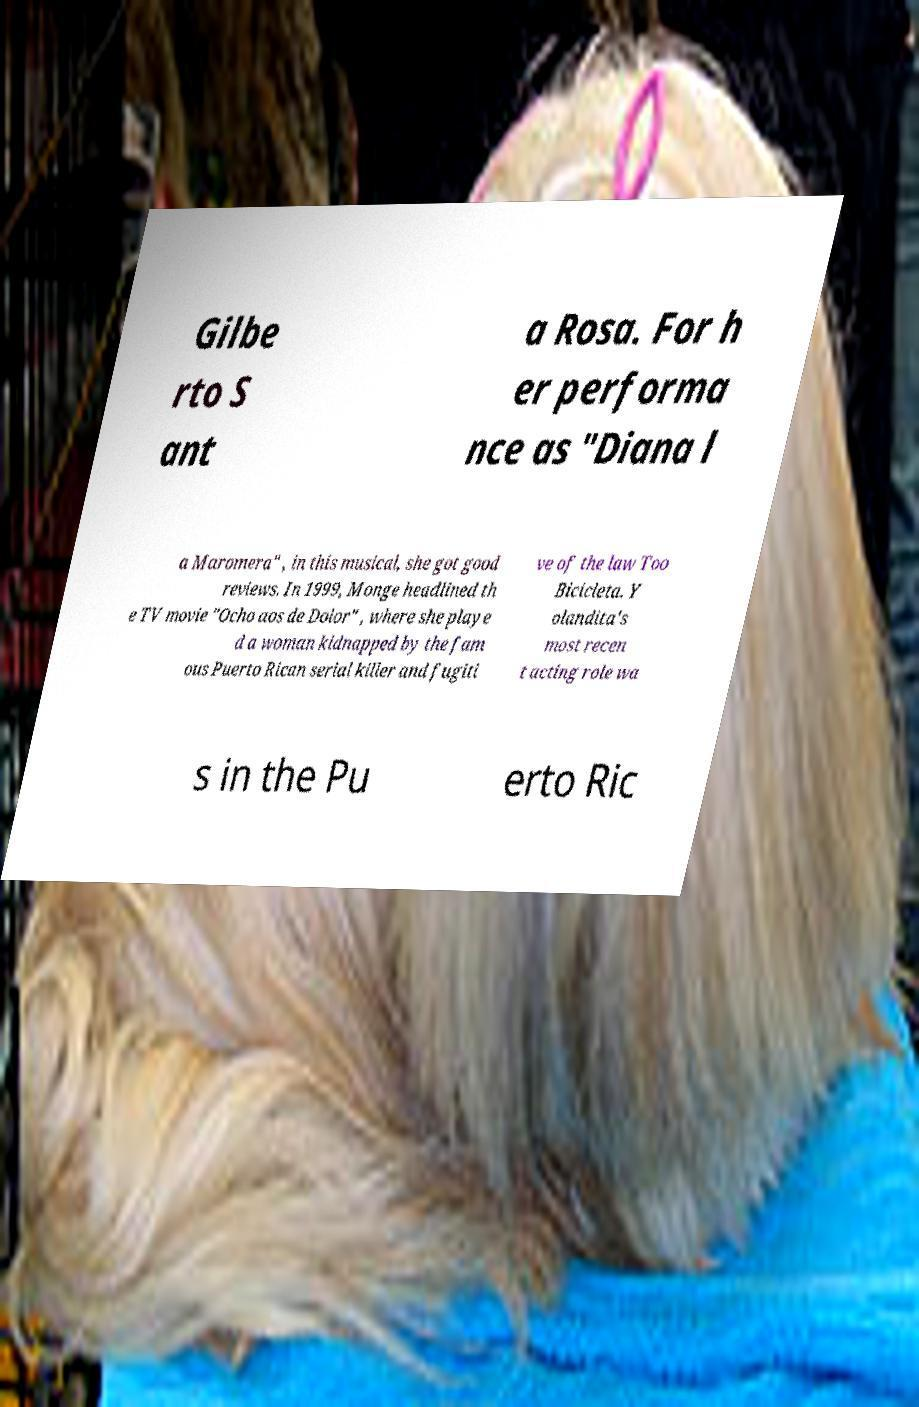Can you accurately transcribe the text from the provided image for me? Gilbe rto S ant a Rosa. For h er performa nce as "Diana l a Maromera" , in this musical, she got good reviews. In 1999, Monge headlined th e TV movie "Ocho aos de Dolor" , where she playe d a woman kidnapped by the fam ous Puerto Rican serial killer and fugiti ve of the law Too Bicicleta. Y olandita's most recen t acting role wa s in the Pu erto Ric 